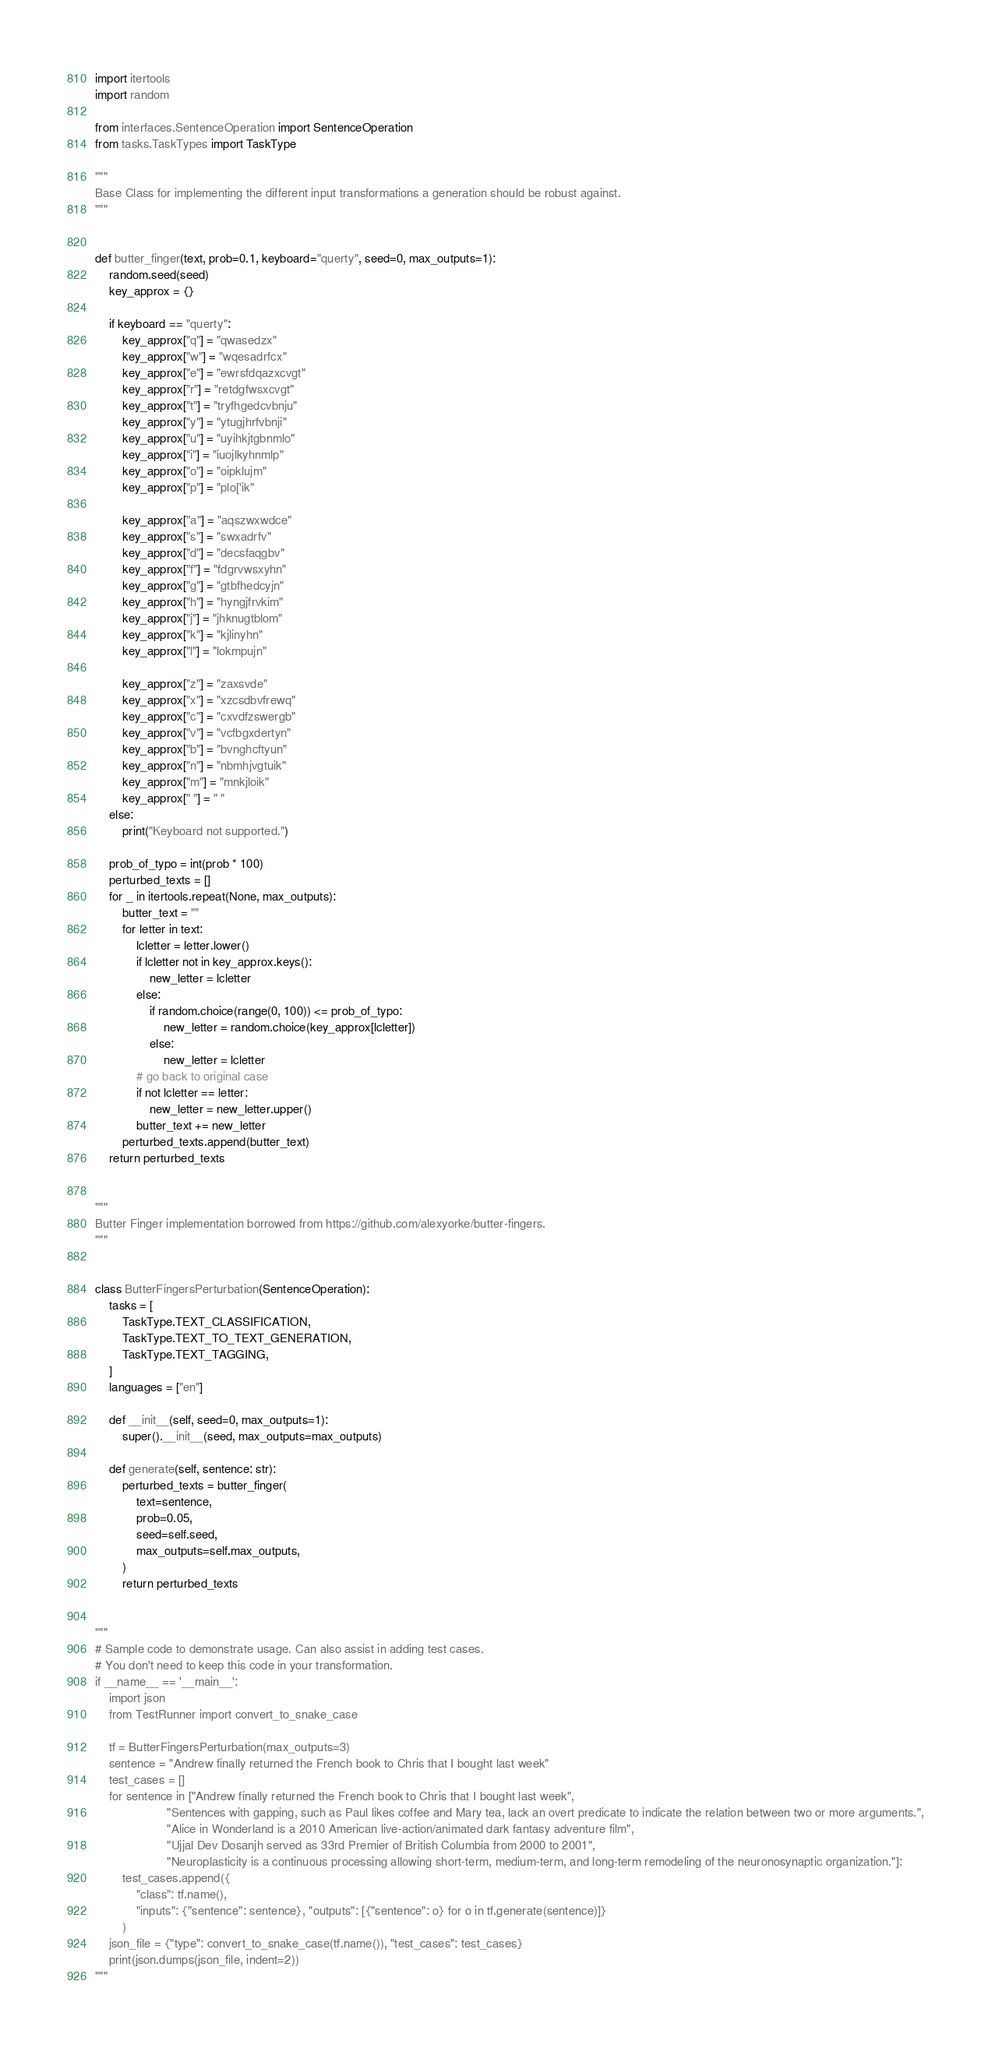Convert code to text. <code><loc_0><loc_0><loc_500><loc_500><_Python_>import itertools
import random

from interfaces.SentenceOperation import SentenceOperation
from tasks.TaskTypes import TaskType

"""
Base Class for implementing the different input transformations a generation should be robust against.
"""


def butter_finger(text, prob=0.1, keyboard="querty", seed=0, max_outputs=1):
    random.seed(seed)
    key_approx = {}

    if keyboard == "querty":
        key_approx["q"] = "qwasedzx"
        key_approx["w"] = "wqesadrfcx"
        key_approx["e"] = "ewrsfdqazxcvgt"
        key_approx["r"] = "retdgfwsxcvgt"
        key_approx["t"] = "tryfhgedcvbnju"
        key_approx["y"] = "ytugjhrfvbnji"
        key_approx["u"] = "uyihkjtgbnmlo"
        key_approx["i"] = "iuojlkyhnmlp"
        key_approx["o"] = "oipklujm"
        key_approx["p"] = "plo['ik"

        key_approx["a"] = "aqszwxwdce"
        key_approx["s"] = "swxadrfv"
        key_approx["d"] = "decsfaqgbv"
        key_approx["f"] = "fdgrvwsxyhn"
        key_approx["g"] = "gtbfhedcyjn"
        key_approx["h"] = "hyngjfrvkim"
        key_approx["j"] = "jhknugtblom"
        key_approx["k"] = "kjlinyhn"
        key_approx["l"] = "lokmpujn"

        key_approx["z"] = "zaxsvde"
        key_approx["x"] = "xzcsdbvfrewq"
        key_approx["c"] = "cxvdfzswergb"
        key_approx["v"] = "vcfbgxdertyn"
        key_approx["b"] = "bvnghcftyun"
        key_approx["n"] = "nbmhjvgtuik"
        key_approx["m"] = "mnkjloik"
        key_approx[" "] = " "
    else:
        print("Keyboard not supported.")

    prob_of_typo = int(prob * 100)
    perturbed_texts = []
    for _ in itertools.repeat(None, max_outputs):
        butter_text = ""
        for letter in text:
            lcletter = letter.lower()
            if lcletter not in key_approx.keys():
                new_letter = lcletter
            else:
                if random.choice(range(0, 100)) <= prob_of_typo:
                    new_letter = random.choice(key_approx[lcletter])
                else:
                    new_letter = lcletter
            # go back to original case
            if not lcletter == letter:
                new_letter = new_letter.upper()
            butter_text += new_letter
        perturbed_texts.append(butter_text)
    return perturbed_texts


"""
Butter Finger implementation borrowed from https://github.com/alexyorke/butter-fingers.
"""


class ButterFingersPerturbation(SentenceOperation):
    tasks = [
        TaskType.TEXT_CLASSIFICATION,
        TaskType.TEXT_TO_TEXT_GENERATION,
        TaskType.TEXT_TAGGING,
    ]
    languages = ["en"]

    def __init__(self, seed=0, max_outputs=1):
        super().__init__(seed, max_outputs=max_outputs)

    def generate(self, sentence: str):
        perturbed_texts = butter_finger(
            text=sentence,
            prob=0.05,
            seed=self.seed,
            max_outputs=self.max_outputs,
        )
        return perturbed_texts


"""
# Sample code to demonstrate usage. Can also assist in adding test cases.
# You don't need to keep this code in your transformation.
if __name__ == '__main__':
    import json
    from TestRunner import convert_to_snake_case

    tf = ButterFingersPerturbation(max_outputs=3)
    sentence = "Andrew finally returned the French book to Chris that I bought last week"
    test_cases = []
    for sentence in ["Andrew finally returned the French book to Chris that I bought last week",
                     "Sentences with gapping, such as Paul likes coffee and Mary tea, lack an overt predicate to indicate the relation between two or more arguments.",
                     "Alice in Wonderland is a 2010 American live-action/animated dark fantasy adventure film",
                     "Ujjal Dev Dosanjh served as 33rd Premier of British Columbia from 2000 to 2001",
                     "Neuroplasticity is a continuous processing allowing short-term, medium-term, and long-term remodeling of the neuronosynaptic organization."]:
        test_cases.append({
            "class": tf.name(),
            "inputs": {"sentence": sentence}, "outputs": [{"sentence": o} for o in tf.generate(sentence)]}
        )
    json_file = {"type": convert_to_snake_case(tf.name()), "test_cases": test_cases}
    print(json.dumps(json_file, indent=2))
"""
</code> 